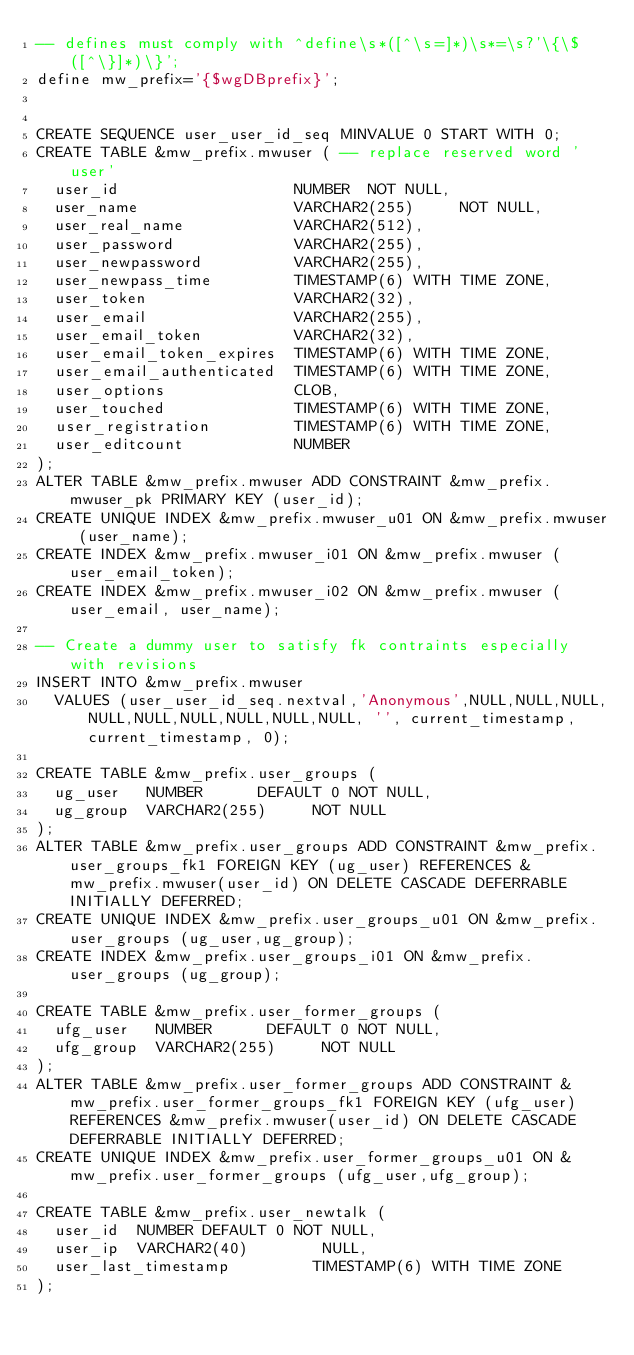Convert code to text. <code><loc_0><loc_0><loc_500><loc_500><_SQL_>-- defines must comply with ^define\s*([^\s=]*)\s*=\s?'\{\$([^\}]*)\}';
define mw_prefix='{$wgDBprefix}';


CREATE SEQUENCE user_user_id_seq MINVALUE 0 START WITH 0;
CREATE TABLE &mw_prefix.mwuser ( -- replace reserved word 'user'
  user_id                   NUMBER  NOT NULL,
  user_name                 VARCHAR2(255)     NOT NULL,
  user_real_name            VARCHAR2(512),
  user_password             VARCHAR2(255),
  user_newpassword          VARCHAR2(255),
  user_newpass_time         TIMESTAMP(6) WITH TIME ZONE,
  user_token                VARCHAR2(32),
  user_email                VARCHAR2(255),
  user_email_token          VARCHAR2(32),
  user_email_token_expires  TIMESTAMP(6) WITH TIME ZONE,
  user_email_authenticated  TIMESTAMP(6) WITH TIME ZONE,
  user_options              CLOB,
  user_touched              TIMESTAMP(6) WITH TIME ZONE,
  user_registration         TIMESTAMP(6) WITH TIME ZONE,
  user_editcount            NUMBER
);
ALTER TABLE &mw_prefix.mwuser ADD CONSTRAINT &mw_prefix.mwuser_pk PRIMARY KEY (user_id);
CREATE UNIQUE INDEX &mw_prefix.mwuser_u01 ON &mw_prefix.mwuser (user_name);
CREATE INDEX &mw_prefix.mwuser_i01 ON &mw_prefix.mwuser (user_email_token);
CREATE INDEX &mw_prefix.mwuser_i02 ON &mw_prefix.mwuser (user_email, user_name);

-- Create a dummy user to satisfy fk contraints especially with revisions
INSERT INTO &mw_prefix.mwuser
  VALUES (user_user_id_seq.nextval,'Anonymous',NULL,NULL,NULL,NULL,NULL,NULL,NULL,NULL,NULL, '', current_timestamp, current_timestamp, 0);

CREATE TABLE &mw_prefix.user_groups (
  ug_user   NUMBER      DEFAULT 0 NOT NULL,
  ug_group  VARCHAR2(255)     NOT NULL
);
ALTER TABLE &mw_prefix.user_groups ADD CONSTRAINT &mw_prefix.user_groups_fk1 FOREIGN KEY (ug_user) REFERENCES &mw_prefix.mwuser(user_id) ON DELETE CASCADE DEFERRABLE INITIALLY DEFERRED;
CREATE UNIQUE INDEX &mw_prefix.user_groups_u01 ON &mw_prefix.user_groups (ug_user,ug_group);
CREATE INDEX &mw_prefix.user_groups_i01 ON &mw_prefix.user_groups (ug_group);

CREATE TABLE &mw_prefix.user_former_groups (
  ufg_user   NUMBER      DEFAULT 0 NOT NULL,
  ufg_group  VARCHAR2(255)     NOT NULL
);
ALTER TABLE &mw_prefix.user_former_groups ADD CONSTRAINT &mw_prefix.user_former_groups_fk1 FOREIGN KEY (ufg_user) REFERENCES &mw_prefix.mwuser(user_id) ON DELETE CASCADE DEFERRABLE INITIALLY DEFERRED;
CREATE UNIQUE INDEX &mw_prefix.user_former_groups_u01 ON &mw_prefix.user_former_groups (ufg_user,ufg_group);

CREATE TABLE &mw_prefix.user_newtalk (
  user_id  NUMBER DEFAULT 0 NOT NULL,
  user_ip  VARCHAR2(40)        NULL,
  user_last_timestamp         TIMESTAMP(6) WITH TIME ZONE
);</code> 